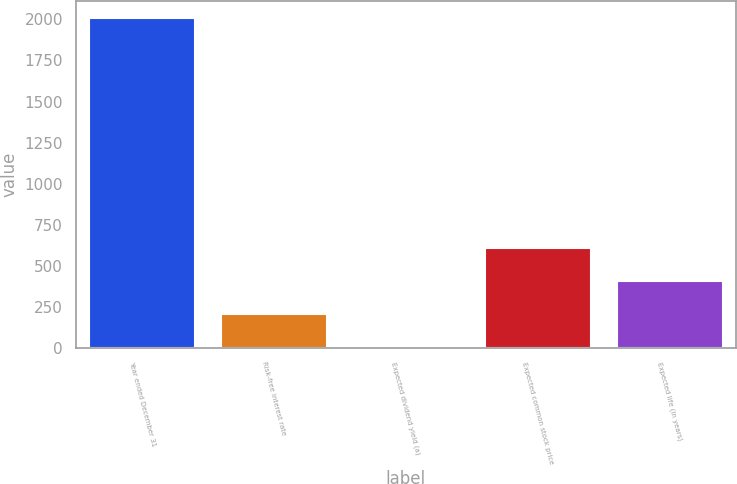Convert chart to OTSL. <chart><loc_0><loc_0><loc_500><loc_500><bar_chart><fcel>Year ended December 31<fcel>Risk-free interest rate<fcel>Expected dividend yield (a)<fcel>Expected common stock price<fcel>Expected life (in years)<nl><fcel>2010<fcel>203.82<fcel>3.13<fcel>605.2<fcel>404.51<nl></chart> 